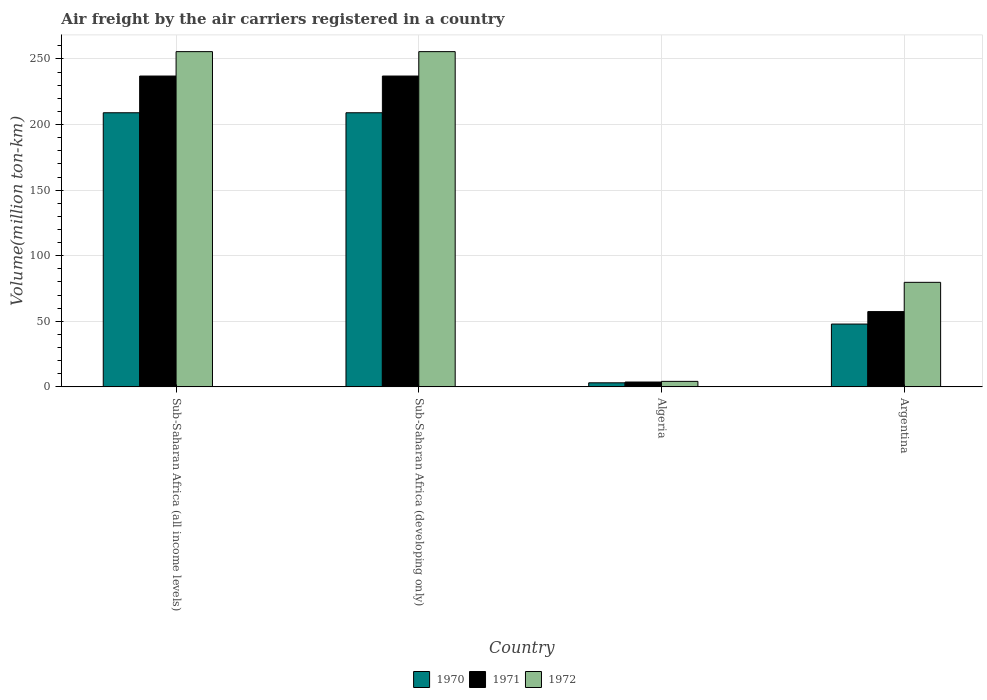How many different coloured bars are there?
Your answer should be compact. 3. Are the number of bars per tick equal to the number of legend labels?
Your answer should be compact. Yes. Are the number of bars on each tick of the X-axis equal?
Ensure brevity in your answer.  Yes. How many bars are there on the 1st tick from the left?
Your answer should be very brief. 3. How many bars are there on the 3rd tick from the right?
Keep it short and to the point. 3. What is the label of the 3rd group of bars from the left?
Provide a short and direct response. Algeria. In how many cases, is the number of bars for a given country not equal to the number of legend labels?
Your answer should be compact. 0. What is the volume of the air carriers in 1971 in Algeria?
Give a very brief answer. 3.7. Across all countries, what is the maximum volume of the air carriers in 1972?
Ensure brevity in your answer.  255.6. Across all countries, what is the minimum volume of the air carriers in 1970?
Your response must be concise. 3.1. In which country was the volume of the air carriers in 1972 maximum?
Your answer should be very brief. Sub-Saharan Africa (all income levels). In which country was the volume of the air carriers in 1970 minimum?
Make the answer very short. Algeria. What is the total volume of the air carriers in 1972 in the graph?
Make the answer very short. 595.1. What is the difference between the volume of the air carriers in 1971 in Sub-Saharan Africa (all income levels) and that in Sub-Saharan Africa (developing only)?
Offer a terse response. 0. What is the difference between the volume of the air carriers in 1972 in Sub-Saharan Africa (all income levels) and the volume of the air carriers in 1970 in Argentina?
Ensure brevity in your answer.  207.7. What is the average volume of the air carriers in 1970 per country?
Provide a succinct answer. 117.25. What is the difference between the volume of the air carriers of/in 1970 and volume of the air carriers of/in 1971 in Sub-Saharan Africa (developing only)?
Ensure brevity in your answer.  -28. What is the difference between the highest and the second highest volume of the air carriers in 1971?
Offer a terse response. -179.6. What is the difference between the highest and the lowest volume of the air carriers in 1972?
Provide a short and direct response. 251.4. In how many countries, is the volume of the air carriers in 1971 greater than the average volume of the air carriers in 1971 taken over all countries?
Offer a terse response. 2. Is it the case that in every country, the sum of the volume of the air carriers in 1970 and volume of the air carriers in 1972 is greater than the volume of the air carriers in 1971?
Ensure brevity in your answer.  Yes. How many bars are there?
Your answer should be compact. 12. Are all the bars in the graph horizontal?
Give a very brief answer. No. How many countries are there in the graph?
Your answer should be very brief. 4. What is the difference between two consecutive major ticks on the Y-axis?
Give a very brief answer. 50. Does the graph contain any zero values?
Make the answer very short. No. What is the title of the graph?
Provide a succinct answer. Air freight by the air carriers registered in a country. Does "1976" appear as one of the legend labels in the graph?
Provide a short and direct response. No. What is the label or title of the X-axis?
Provide a succinct answer. Country. What is the label or title of the Y-axis?
Offer a very short reply. Volume(million ton-km). What is the Volume(million ton-km) of 1970 in Sub-Saharan Africa (all income levels)?
Provide a short and direct response. 209. What is the Volume(million ton-km) in 1971 in Sub-Saharan Africa (all income levels)?
Your response must be concise. 237. What is the Volume(million ton-km) of 1972 in Sub-Saharan Africa (all income levels)?
Give a very brief answer. 255.6. What is the Volume(million ton-km) in 1970 in Sub-Saharan Africa (developing only)?
Offer a terse response. 209. What is the Volume(million ton-km) in 1971 in Sub-Saharan Africa (developing only)?
Provide a short and direct response. 237. What is the Volume(million ton-km) in 1972 in Sub-Saharan Africa (developing only)?
Offer a terse response. 255.6. What is the Volume(million ton-km) of 1970 in Algeria?
Provide a short and direct response. 3.1. What is the Volume(million ton-km) of 1971 in Algeria?
Offer a very short reply. 3.7. What is the Volume(million ton-km) in 1972 in Algeria?
Your response must be concise. 4.2. What is the Volume(million ton-km) of 1970 in Argentina?
Offer a terse response. 47.9. What is the Volume(million ton-km) in 1971 in Argentina?
Give a very brief answer. 57.4. What is the Volume(million ton-km) in 1972 in Argentina?
Your answer should be very brief. 79.7. Across all countries, what is the maximum Volume(million ton-km) in 1970?
Keep it short and to the point. 209. Across all countries, what is the maximum Volume(million ton-km) of 1971?
Your response must be concise. 237. Across all countries, what is the maximum Volume(million ton-km) in 1972?
Make the answer very short. 255.6. Across all countries, what is the minimum Volume(million ton-km) in 1970?
Give a very brief answer. 3.1. Across all countries, what is the minimum Volume(million ton-km) in 1971?
Keep it short and to the point. 3.7. Across all countries, what is the minimum Volume(million ton-km) in 1972?
Give a very brief answer. 4.2. What is the total Volume(million ton-km) of 1970 in the graph?
Make the answer very short. 469. What is the total Volume(million ton-km) of 1971 in the graph?
Your answer should be compact. 535.1. What is the total Volume(million ton-km) of 1972 in the graph?
Your answer should be very brief. 595.1. What is the difference between the Volume(million ton-km) in 1970 in Sub-Saharan Africa (all income levels) and that in Algeria?
Give a very brief answer. 205.9. What is the difference between the Volume(million ton-km) in 1971 in Sub-Saharan Africa (all income levels) and that in Algeria?
Provide a succinct answer. 233.3. What is the difference between the Volume(million ton-km) of 1972 in Sub-Saharan Africa (all income levels) and that in Algeria?
Your answer should be compact. 251.4. What is the difference between the Volume(million ton-km) in 1970 in Sub-Saharan Africa (all income levels) and that in Argentina?
Your answer should be compact. 161.1. What is the difference between the Volume(million ton-km) in 1971 in Sub-Saharan Africa (all income levels) and that in Argentina?
Keep it short and to the point. 179.6. What is the difference between the Volume(million ton-km) in 1972 in Sub-Saharan Africa (all income levels) and that in Argentina?
Make the answer very short. 175.9. What is the difference between the Volume(million ton-km) in 1970 in Sub-Saharan Africa (developing only) and that in Algeria?
Your response must be concise. 205.9. What is the difference between the Volume(million ton-km) in 1971 in Sub-Saharan Africa (developing only) and that in Algeria?
Make the answer very short. 233.3. What is the difference between the Volume(million ton-km) in 1972 in Sub-Saharan Africa (developing only) and that in Algeria?
Give a very brief answer. 251.4. What is the difference between the Volume(million ton-km) of 1970 in Sub-Saharan Africa (developing only) and that in Argentina?
Your response must be concise. 161.1. What is the difference between the Volume(million ton-km) in 1971 in Sub-Saharan Africa (developing only) and that in Argentina?
Give a very brief answer. 179.6. What is the difference between the Volume(million ton-km) of 1972 in Sub-Saharan Africa (developing only) and that in Argentina?
Ensure brevity in your answer.  175.9. What is the difference between the Volume(million ton-km) in 1970 in Algeria and that in Argentina?
Make the answer very short. -44.8. What is the difference between the Volume(million ton-km) in 1971 in Algeria and that in Argentina?
Keep it short and to the point. -53.7. What is the difference between the Volume(million ton-km) of 1972 in Algeria and that in Argentina?
Make the answer very short. -75.5. What is the difference between the Volume(million ton-km) of 1970 in Sub-Saharan Africa (all income levels) and the Volume(million ton-km) of 1972 in Sub-Saharan Africa (developing only)?
Your answer should be compact. -46.6. What is the difference between the Volume(million ton-km) of 1971 in Sub-Saharan Africa (all income levels) and the Volume(million ton-km) of 1972 in Sub-Saharan Africa (developing only)?
Your answer should be compact. -18.6. What is the difference between the Volume(million ton-km) of 1970 in Sub-Saharan Africa (all income levels) and the Volume(million ton-km) of 1971 in Algeria?
Give a very brief answer. 205.3. What is the difference between the Volume(million ton-km) of 1970 in Sub-Saharan Africa (all income levels) and the Volume(million ton-km) of 1972 in Algeria?
Make the answer very short. 204.8. What is the difference between the Volume(million ton-km) in 1971 in Sub-Saharan Africa (all income levels) and the Volume(million ton-km) in 1972 in Algeria?
Provide a short and direct response. 232.8. What is the difference between the Volume(million ton-km) in 1970 in Sub-Saharan Africa (all income levels) and the Volume(million ton-km) in 1971 in Argentina?
Your answer should be compact. 151.6. What is the difference between the Volume(million ton-km) of 1970 in Sub-Saharan Africa (all income levels) and the Volume(million ton-km) of 1972 in Argentina?
Offer a terse response. 129.3. What is the difference between the Volume(million ton-km) in 1971 in Sub-Saharan Africa (all income levels) and the Volume(million ton-km) in 1972 in Argentina?
Ensure brevity in your answer.  157.3. What is the difference between the Volume(million ton-km) in 1970 in Sub-Saharan Africa (developing only) and the Volume(million ton-km) in 1971 in Algeria?
Your answer should be compact. 205.3. What is the difference between the Volume(million ton-km) in 1970 in Sub-Saharan Africa (developing only) and the Volume(million ton-km) in 1972 in Algeria?
Keep it short and to the point. 204.8. What is the difference between the Volume(million ton-km) in 1971 in Sub-Saharan Africa (developing only) and the Volume(million ton-km) in 1972 in Algeria?
Provide a short and direct response. 232.8. What is the difference between the Volume(million ton-km) of 1970 in Sub-Saharan Africa (developing only) and the Volume(million ton-km) of 1971 in Argentina?
Make the answer very short. 151.6. What is the difference between the Volume(million ton-km) in 1970 in Sub-Saharan Africa (developing only) and the Volume(million ton-km) in 1972 in Argentina?
Provide a succinct answer. 129.3. What is the difference between the Volume(million ton-km) in 1971 in Sub-Saharan Africa (developing only) and the Volume(million ton-km) in 1972 in Argentina?
Keep it short and to the point. 157.3. What is the difference between the Volume(million ton-km) of 1970 in Algeria and the Volume(million ton-km) of 1971 in Argentina?
Your answer should be compact. -54.3. What is the difference between the Volume(million ton-km) of 1970 in Algeria and the Volume(million ton-km) of 1972 in Argentina?
Make the answer very short. -76.6. What is the difference between the Volume(million ton-km) in 1971 in Algeria and the Volume(million ton-km) in 1972 in Argentina?
Provide a succinct answer. -76. What is the average Volume(million ton-km) in 1970 per country?
Your answer should be very brief. 117.25. What is the average Volume(million ton-km) in 1971 per country?
Your answer should be very brief. 133.78. What is the average Volume(million ton-km) of 1972 per country?
Give a very brief answer. 148.78. What is the difference between the Volume(million ton-km) in 1970 and Volume(million ton-km) in 1972 in Sub-Saharan Africa (all income levels)?
Your response must be concise. -46.6. What is the difference between the Volume(million ton-km) of 1971 and Volume(million ton-km) of 1972 in Sub-Saharan Africa (all income levels)?
Your answer should be very brief. -18.6. What is the difference between the Volume(million ton-km) of 1970 and Volume(million ton-km) of 1972 in Sub-Saharan Africa (developing only)?
Provide a succinct answer. -46.6. What is the difference between the Volume(million ton-km) of 1971 and Volume(million ton-km) of 1972 in Sub-Saharan Africa (developing only)?
Give a very brief answer. -18.6. What is the difference between the Volume(million ton-km) in 1970 and Volume(million ton-km) in 1971 in Algeria?
Provide a short and direct response. -0.6. What is the difference between the Volume(million ton-km) in 1971 and Volume(million ton-km) in 1972 in Algeria?
Keep it short and to the point. -0.5. What is the difference between the Volume(million ton-km) of 1970 and Volume(million ton-km) of 1972 in Argentina?
Your response must be concise. -31.8. What is the difference between the Volume(million ton-km) in 1971 and Volume(million ton-km) in 1972 in Argentina?
Offer a terse response. -22.3. What is the ratio of the Volume(million ton-km) in 1970 in Sub-Saharan Africa (all income levels) to that in Sub-Saharan Africa (developing only)?
Offer a terse response. 1. What is the ratio of the Volume(million ton-km) in 1972 in Sub-Saharan Africa (all income levels) to that in Sub-Saharan Africa (developing only)?
Your answer should be very brief. 1. What is the ratio of the Volume(million ton-km) in 1970 in Sub-Saharan Africa (all income levels) to that in Algeria?
Your answer should be compact. 67.42. What is the ratio of the Volume(million ton-km) in 1971 in Sub-Saharan Africa (all income levels) to that in Algeria?
Make the answer very short. 64.05. What is the ratio of the Volume(million ton-km) in 1972 in Sub-Saharan Africa (all income levels) to that in Algeria?
Make the answer very short. 60.86. What is the ratio of the Volume(million ton-km) of 1970 in Sub-Saharan Africa (all income levels) to that in Argentina?
Provide a succinct answer. 4.36. What is the ratio of the Volume(million ton-km) of 1971 in Sub-Saharan Africa (all income levels) to that in Argentina?
Ensure brevity in your answer.  4.13. What is the ratio of the Volume(million ton-km) in 1972 in Sub-Saharan Africa (all income levels) to that in Argentina?
Keep it short and to the point. 3.21. What is the ratio of the Volume(million ton-km) in 1970 in Sub-Saharan Africa (developing only) to that in Algeria?
Your response must be concise. 67.42. What is the ratio of the Volume(million ton-km) in 1971 in Sub-Saharan Africa (developing only) to that in Algeria?
Offer a terse response. 64.05. What is the ratio of the Volume(million ton-km) in 1972 in Sub-Saharan Africa (developing only) to that in Algeria?
Offer a very short reply. 60.86. What is the ratio of the Volume(million ton-km) of 1970 in Sub-Saharan Africa (developing only) to that in Argentina?
Your answer should be very brief. 4.36. What is the ratio of the Volume(million ton-km) of 1971 in Sub-Saharan Africa (developing only) to that in Argentina?
Make the answer very short. 4.13. What is the ratio of the Volume(million ton-km) of 1972 in Sub-Saharan Africa (developing only) to that in Argentina?
Your answer should be very brief. 3.21. What is the ratio of the Volume(million ton-km) in 1970 in Algeria to that in Argentina?
Make the answer very short. 0.06. What is the ratio of the Volume(million ton-km) in 1971 in Algeria to that in Argentina?
Ensure brevity in your answer.  0.06. What is the ratio of the Volume(million ton-km) in 1972 in Algeria to that in Argentina?
Make the answer very short. 0.05. What is the difference between the highest and the lowest Volume(million ton-km) of 1970?
Ensure brevity in your answer.  205.9. What is the difference between the highest and the lowest Volume(million ton-km) in 1971?
Your answer should be compact. 233.3. What is the difference between the highest and the lowest Volume(million ton-km) in 1972?
Your answer should be very brief. 251.4. 